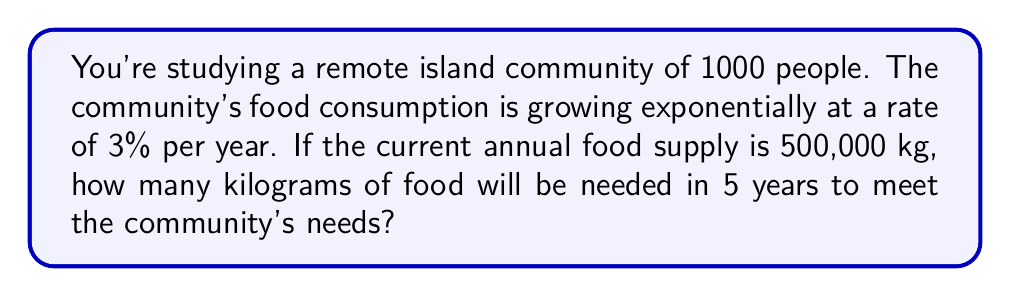Help me with this question. To solve this problem, we'll use the exponential growth formula:

$$A = P(1 + r)^t$$

Where:
$A$ = Final amount
$P$ = Initial amount (principal)
$r$ = Growth rate (as a decimal)
$t$ = Time period

Given:
$P = 500,000$ kg
$r = 3\% = 0.03$
$t = 5$ years

Let's substitute these values into the formula:

$$A = 500,000(1 + 0.03)^5$$

Now, let's solve step-by-step:

1) First, calculate $(1 + 0.03)^5$:
   $$(1.03)^5 = 1.159274$$

2) Multiply this result by the initial amount:
   $$500,000 \times 1.159274 = 579,637$$

3) Round to the nearest whole number (as we can't have fractional kilograms of food):
   $$579,637 \approx 579,637\text{ kg}$$

Therefore, in 5 years, the community will need approximately 579,637 kg of food to meet their needs based on the exponential growth of consumption.
Answer: 579,637 kg 